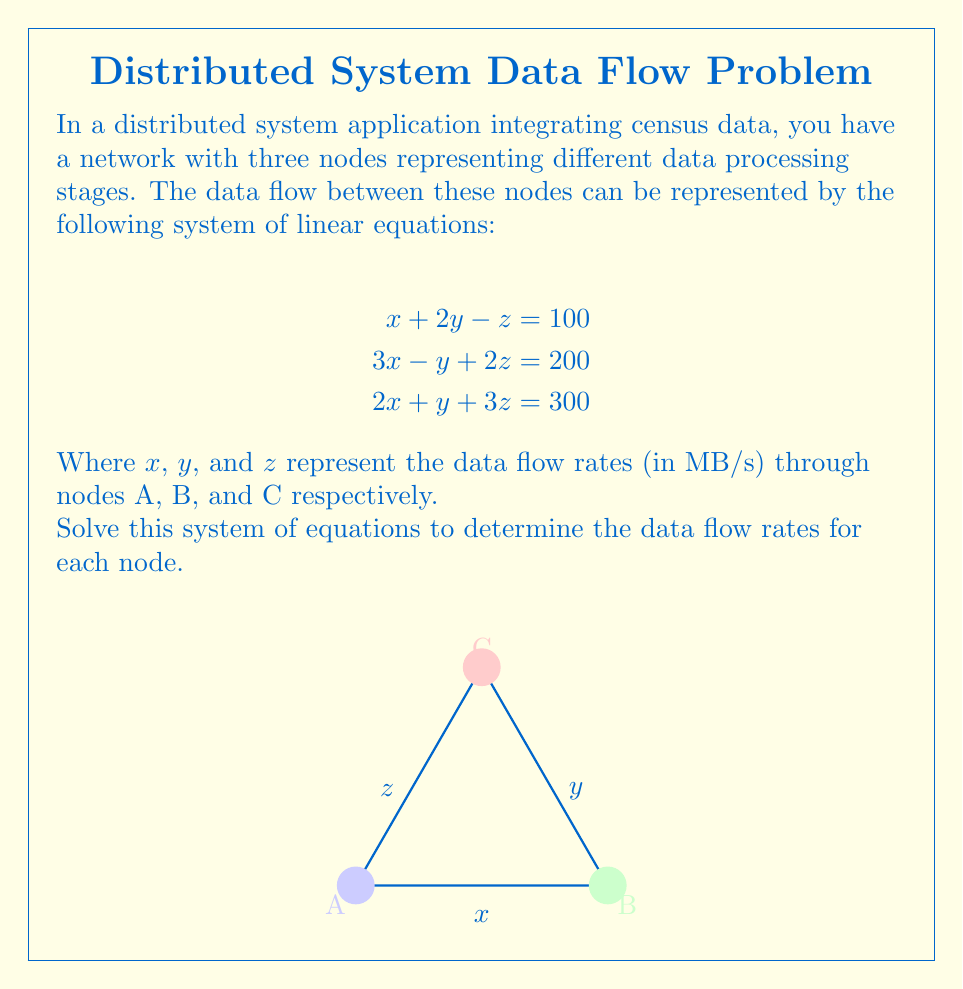Show me your answer to this math problem. To solve this system of linear equations, we'll use the Gaussian elimination method:

1) First, write the augmented matrix:

   $$
   \begin{bmatrix}
   1 & 2 & -1 & 100 \\
   3 & -1 & 2 & 200 \\
   2 & 1 & 3 & 300
   \end{bmatrix}
   $$

2) Multiply the first row by -3 and add it to the second row:

   $$
   \begin{bmatrix}
   1 & 2 & -1 & 100 \\
   0 & -7 & 5 & -100 \\
   2 & 1 & 3 & 300
   \end{bmatrix}
   $$

3) Multiply the first row by -2 and add it to the third row:

   $$
   \begin{bmatrix}
   1 & 2 & -1 & 100 \\
   0 & -7 & 5 & -100 \\
   0 & -3 & 5 & 100
   \end{bmatrix}
   $$

4) Multiply the second row by 3 and add it to the third row:

   $$
   \begin{bmatrix}
   1 & 2 & -1 & 100 \\
   0 & -7 & 5 & -100 \\
   0 & 0 & 20 & 200
   \end{bmatrix}
   $$

5) Now we have an upper triangular matrix. Solve for z:

   $20z = 200$
   $z = 10$

6) Substitute z = 10 into the second equation:

   $-7y + 5(10) = -100$
   $-7y + 50 = -100$
   $-7y = -150$
   $y = \frac{150}{7} \approx 21.43$

7) Substitute z = 10 and y ≈ 21.43 into the first equation:

   $x + 2(21.43) - 10 = 100$
   $x + 42.86 - 10 = 100$
   $x = 67.14$

Therefore, the solution is approximately:
$x \approx 67.14$, $y \approx 21.43$, $z = 10$
Answer: $x \approx 67.14$ MB/s, $y \approx 21.43$ MB/s, $z = 10$ MB/s 